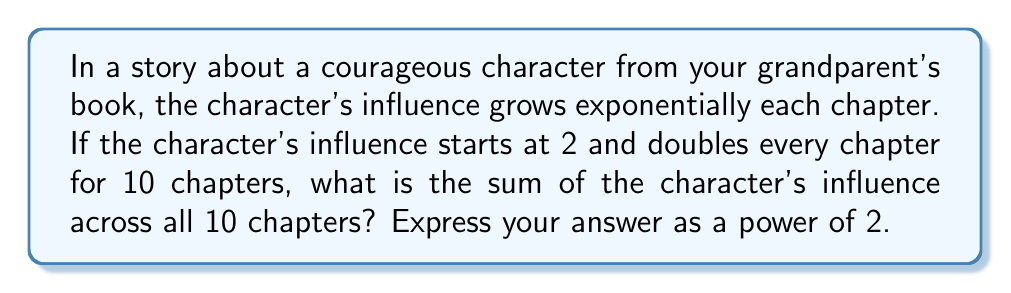Provide a solution to this math problem. Let's approach this step-by-step:

1) The sequence of the character's influence over the 10 chapters forms a geometric sequence:
   $2, 4, 8, 16, 32, 64, 128, 256, 512, 1024$

2) This can be written as:
   $2^1, 2^2, 2^3, 2^4, 2^5, 2^6, 2^7, 2^8, 2^9, 2^{10}$

3) We need to find the sum of this geometric series. The formula for the sum of a geometric series is:

   $$S_n = \frac{a(1-r^n)}{1-r}$$

   where $a$ is the first term, $r$ is the common ratio, and $n$ is the number of terms.

4) In our case:
   $a = 2$
   $r = 2$
   $n = 10$

5) Substituting these values:

   $$S_{10} = \frac{2(1-2^{10})}{1-2} = \frac{2(1-1024)}{-1} = 2(1024-1) = 2046$$

6) We can simplify this further:
   $2046 = 2^{11} - 2$

Therefore, the sum of the character's influence across all 10 chapters is $2^{11} - 2$.
Answer: $2^{11} - 2$ 